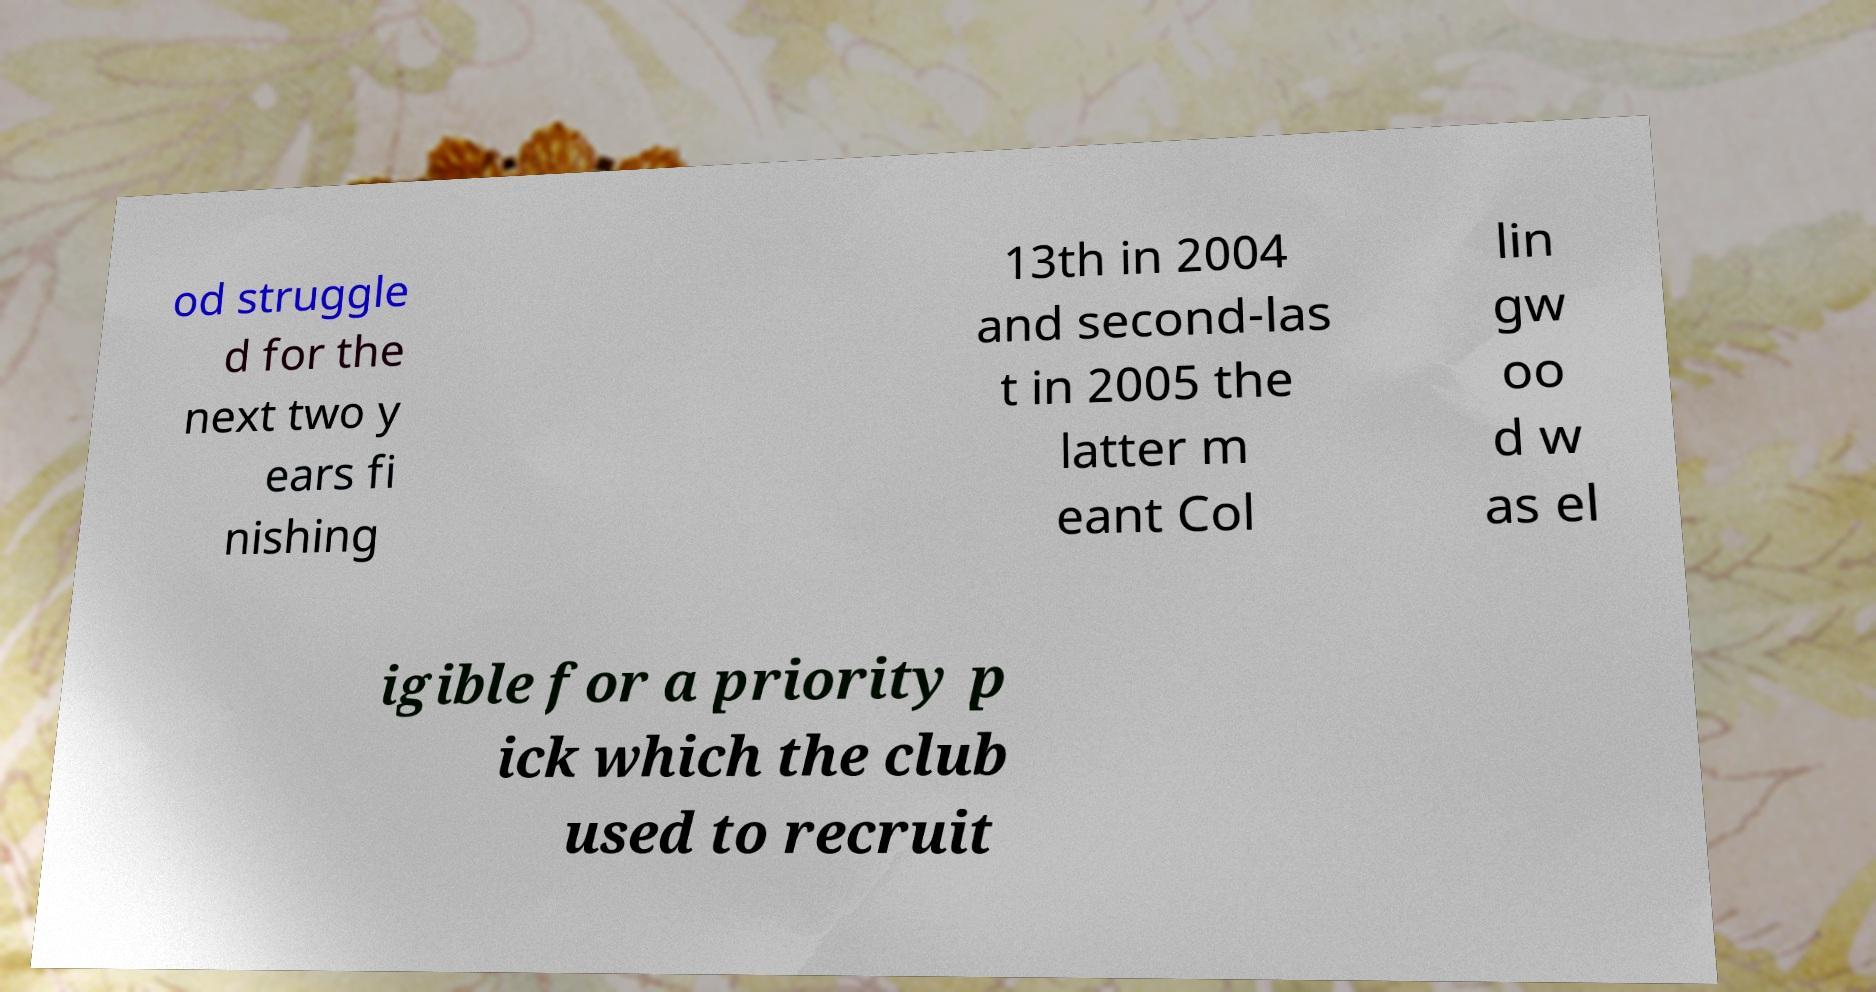Can you accurately transcribe the text from the provided image for me? od struggle d for the next two y ears fi nishing 13th in 2004 and second-las t in 2005 the latter m eant Col lin gw oo d w as el igible for a priority p ick which the club used to recruit 